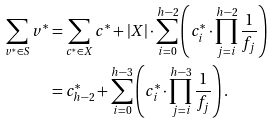Convert formula to latex. <formula><loc_0><loc_0><loc_500><loc_500>\sum _ { v ^ { * } \in S } v ^ { * } & = \sum _ { c ^ { * } \in X } c ^ { * } + | X | \cdot \sum _ { i = 0 } ^ { h - 2 } \left ( c ^ { * } _ { i } \cdot \prod _ { j = i } ^ { h - 2 } \frac { 1 } { f _ { j } } \right ) \\ & = c ^ { * } _ { h - 2 } + \sum _ { i = 0 } ^ { h - 3 } \left ( c ^ { * } _ { i } \cdot \prod _ { j = i } ^ { h - 3 } \frac { 1 } { f _ { j } } \right ) .</formula> 